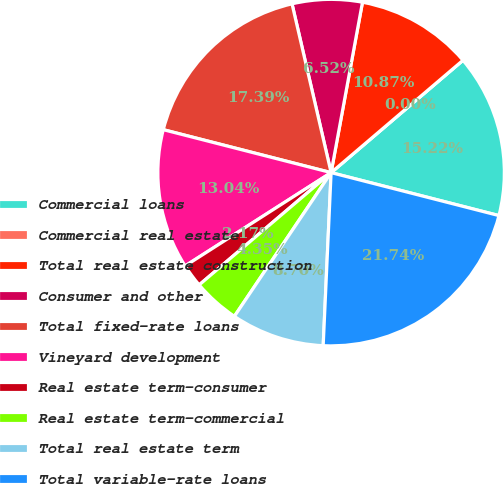Convert chart to OTSL. <chart><loc_0><loc_0><loc_500><loc_500><pie_chart><fcel>Commercial loans<fcel>Commercial real estate<fcel>Total real estate construction<fcel>Consumer and other<fcel>Total fixed-rate loans<fcel>Vineyard development<fcel>Real estate term-consumer<fcel>Real estate term-commercial<fcel>Total real estate term<fcel>Total variable-rate loans<nl><fcel>15.22%<fcel>0.0%<fcel>10.87%<fcel>6.52%<fcel>17.39%<fcel>13.04%<fcel>2.17%<fcel>4.35%<fcel>8.7%<fcel>21.74%<nl></chart> 